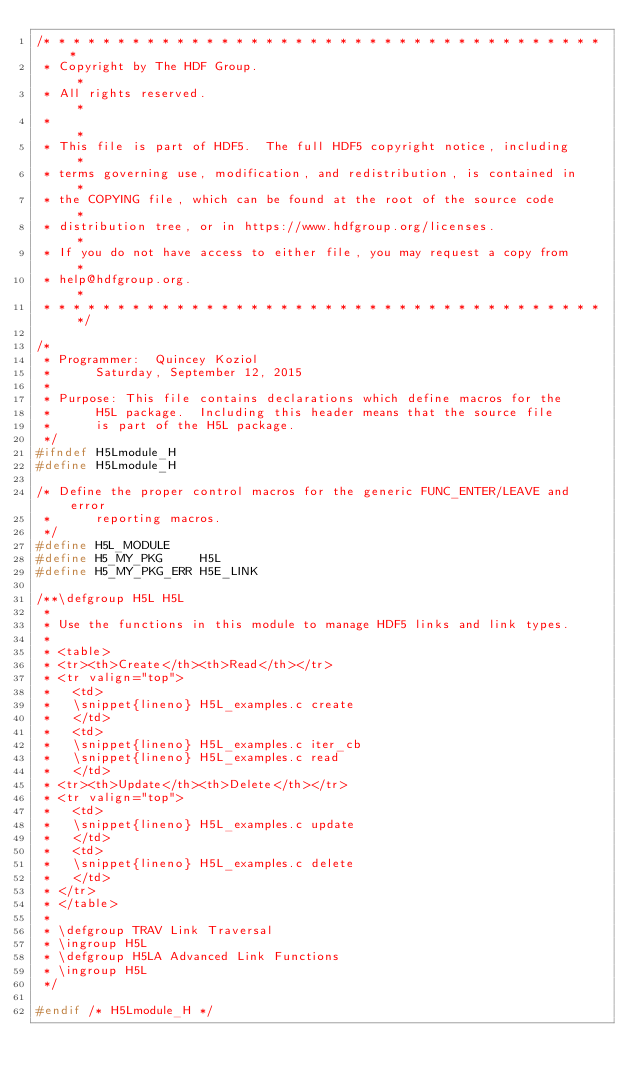<code> <loc_0><loc_0><loc_500><loc_500><_C_>/* * * * * * * * * * * * * * * * * * * * * * * * * * * * * * * * * * * * * * *
 * Copyright by The HDF Group.                                               *
 * All rights reserved.                                                      *
 *                                                                           *
 * This file is part of HDF5.  The full HDF5 copyright notice, including     *
 * terms governing use, modification, and redistribution, is contained in    *
 * the COPYING file, which can be found at the root of the source code       *
 * distribution tree, or in https://www.hdfgroup.org/licenses.               *
 * If you do not have access to either file, you may request a copy from     *
 * help@hdfgroup.org.                                                        *
 * * * * * * * * * * * * * * * * * * * * * * * * * * * * * * * * * * * * * * */

/*
 * Programmer:	Quincey Koziol
 *		Saturday, September 12, 2015
 *
 * Purpose:	This file contains declarations which define macros for the
 *		H5L package.  Including this header means that the source file
 *		is part of the H5L package.
 */
#ifndef H5Lmodule_H
#define H5Lmodule_H

/* Define the proper control macros for the generic FUNC_ENTER/LEAVE and error
 *      reporting macros.
 */
#define H5L_MODULE
#define H5_MY_PKG     H5L
#define H5_MY_PKG_ERR H5E_LINK

/**\defgroup H5L H5L
 *
 * Use the functions in this module to manage HDF5 links and link types.
 *
 * <table>
 * <tr><th>Create</th><th>Read</th></tr>
 * <tr valign="top">
 *   <td>
 *   \snippet{lineno} H5L_examples.c create
 *   </td>
 *   <td>
 *   \snippet{lineno} H5L_examples.c iter_cb
 *   \snippet{lineno} H5L_examples.c read
 *   </td>
 * <tr><th>Update</th><th>Delete</th></tr>
 * <tr valign="top">
 *   <td>
 *   \snippet{lineno} H5L_examples.c update
 *   </td>
 *   <td>
 *   \snippet{lineno} H5L_examples.c delete
 *   </td>
 * </tr>
 * </table>
 *
 * \defgroup TRAV Link Traversal
 * \ingroup H5L
 * \defgroup H5LA Advanced Link Functions
 * \ingroup H5L
 */

#endif /* H5Lmodule_H */
</code> 